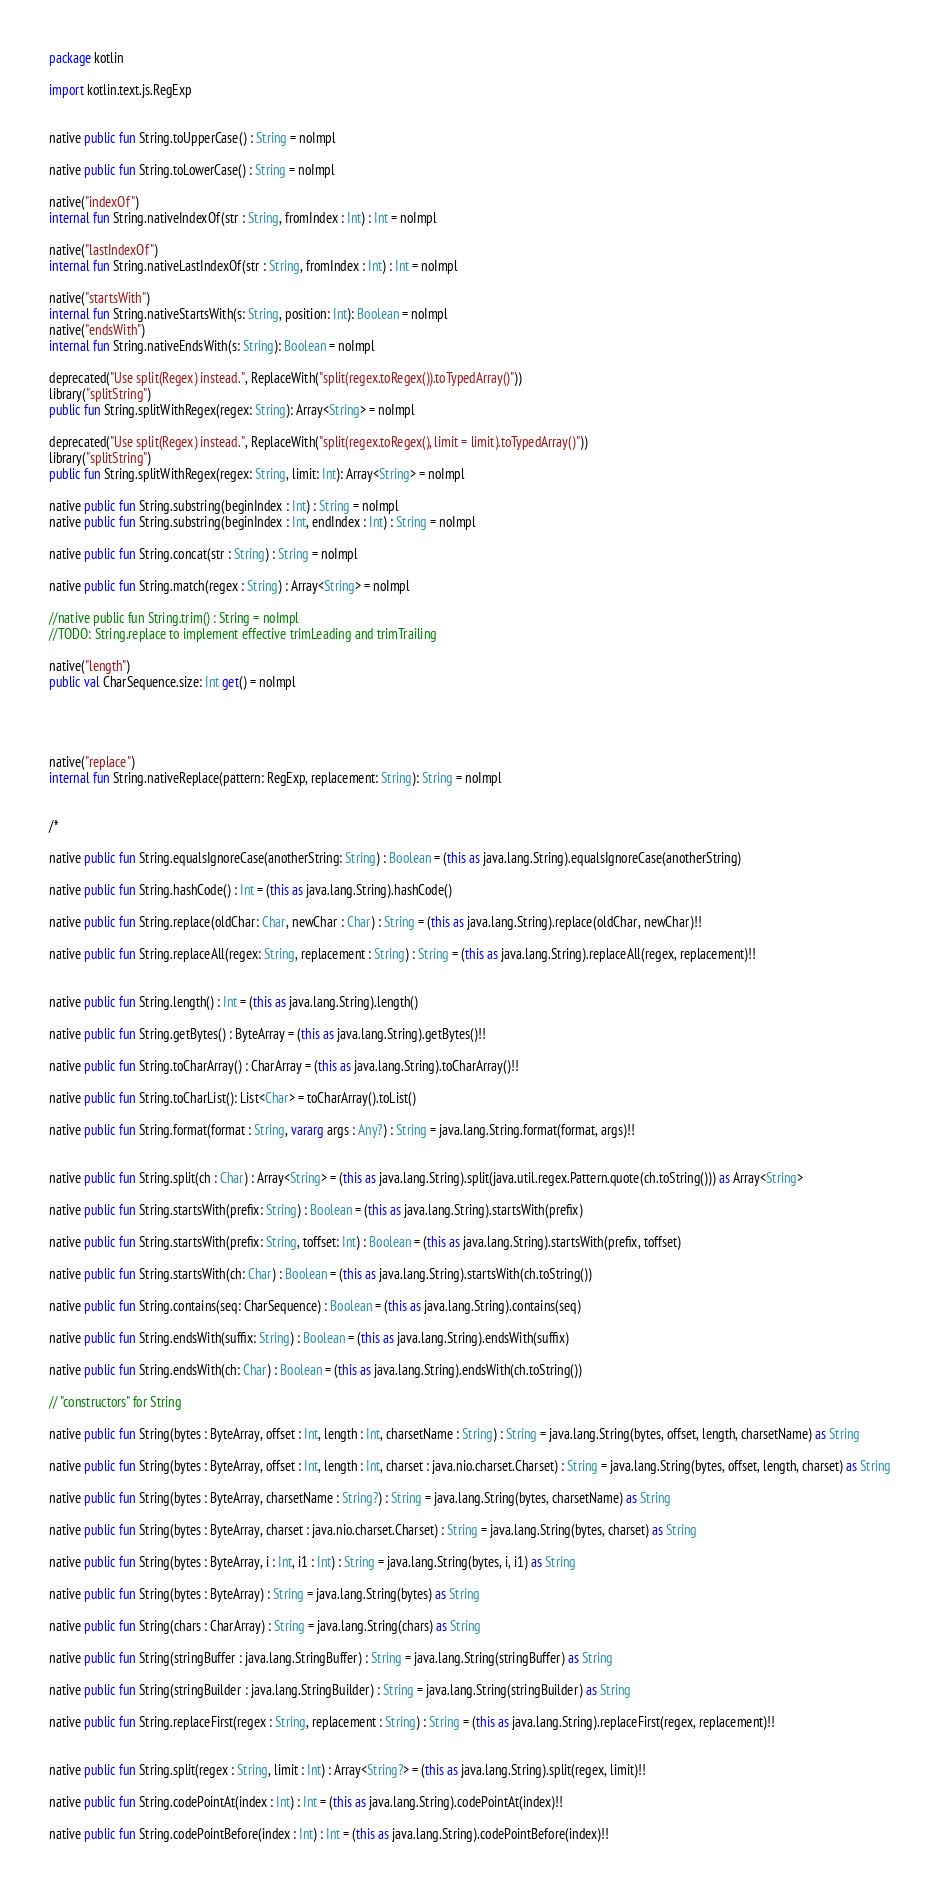Convert code to text. <code><loc_0><loc_0><loc_500><loc_500><_Kotlin_>package kotlin

import kotlin.text.js.RegExp


native public fun String.toUpperCase() : String = noImpl

native public fun String.toLowerCase() : String = noImpl

native("indexOf")
internal fun String.nativeIndexOf(str : String, fromIndex : Int) : Int = noImpl

native("lastIndexOf")
internal fun String.nativeLastIndexOf(str : String, fromIndex : Int) : Int = noImpl

native("startsWith")
internal fun String.nativeStartsWith(s: String, position: Int): Boolean = noImpl
native("endsWith")
internal fun String.nativeEndsWith(s: String): Boolean = noImpl

deprecated("Use split(Regex) instead.", ReplaceWith("split(regex.toRegex()).toTypedArray()"))
library("splitString")
public fun String.splitWithRegex(regex: String): Array<String> = noImpl

deprecated("Use split(Regex) instead.", ReplaceWith("split(regex.toRegex(), limit = limit).toTypedArray()"))
library("splitString")
public fun String.splitWithRegex(regex: String, limit: Int): Array<String> = noImpl

native public fun String.substring(beginIndex : Int) : String = noImpl
native public fun String.substring(beginIndex : Int, endIndex : Int) : String = noImpl

native public fun String.concat(str : String) : String = noImpl

native public fun String.match(regex : String) : Array<String> = noImpl

//native public fun String.trim() : String = noImpl
//TODO: String.replace to implement effective trimLeading and trimTrailing

native("length")
public val CharSequence.size: Int get() = noImpl




native("replace")
internal fun String.nativeReplace(pattern: RegExp, replacement: String): String = noImpl


/*

native public fun String.equalsIgnoreCase(anotherString: String) : Boolean = (this as java.lang.String).equalsIgnoreCase(anotherString)

native public fun String.hashCode() : Int = (this as java.lang.String).hashCode()

native public fun String.replace(oldChar: Char, newChar : Char) : String = (this as java.lang.String).replace(oldChar, newChar)!!

native public fun String.replaceAll(regex: String, replacement : String) : String = (this as java.lang.String).replaceAll(regex, replacement)!!


native public fun String.length() : Int = (this as java.lang.String).length()

native public fun String.getBytes() : ByteArray = (this as java.lang.String).getBytes()!!

native public fun String.toCharArray() : CharArray = (this as java.lang.String).toCharArray()!!

native public fun String.toCharList(): List<Char> = toCharArray().toList()

native public fun String.format(format : String, vararg args : Any?) : String = java.lang.String.format(format, args)!!


native public fun String.split(ch : Char) : Array<String> = (this as java.lang.String).split(java.util.regex.Pattern.quote(ch.toString())) as Array<String>

native public fun String.startsWith(prefix: String) : Boolean = (this as java.lang.String).startsWith(prefix)

native public fun String.startsWith(prefix: String, toffset: Int) : Boolean = (this as java.lang.String).startsWith(prefix, toffset)

native public fun String.startsWith(ch: Char) : Boolean = (this as java.lang.String).startsWith(ch.toString())

native public fun String.contains(seq: CharSequence) : Boolean = (this as java.lang.String).contains(seq)

native public fun String.endsWith(suffix: String) : Boolean = (this as java.lang.String).endsWith(suffix)

native public fun String.endsWith(ch: Char) : Boolean = (this as java.lang.String).endsWith(ch.toString())

// "constructors" for String

native public fun String(bytes : ByteArray, offset : Int, length : Int, charsetName : String) : String = java.lang.String(bytes, offset, length, charsetName) as String

native public fun String(bytes : ByteArray, offset : Int, length : Int, charset : java.nio.charset.Charset) : String = java.lang.String(bytes, offset, length, charset) as String

native public fun String(bytes : ByteArray, charsetName : String?) : String = java.lang.String(bytes, charsetName) as String

native public fun String(bytes : ByteArray, charset : java.nio.charset.Charset) : String = java.lang.String(bytes, charset) as String

native public fun String(bytes : ByteArray, i : Int, i1 : Int) : String = java.lang.String(bytes, i, i1) as String

native public fun String(bytes : ByteArray) : String = java.lang.String(bytes) as String

native public fun String(chars : CharArray) : String = java.lang.String(chars) as String

native public fun String(stringBuffer : java.lang.StringBuffer) : String = java.lang.String(stringBuffer) as String

native public fun String(stringBuilder : java.lang.StringBuilder) : String = java.lang.String(stringBuilder) as String

native public fun String.replaceFirst(regex : String, replacement : String) : String = (this as java.lang.String).replaceFirst(regex, replacement)!!


native public fun String.split(regex : String, limit : Int) : Array<String?> = (this as java.lang.String).split(regex, limit)!!

native public fun String.codePointAt(index : Int) : Int = (this as java.lang.String).codePointAt(index)!!

native public fun String.codePointBefore(index : Int) : Int = (this as java.lang.String).codePointBefore(index)!!
</code> 